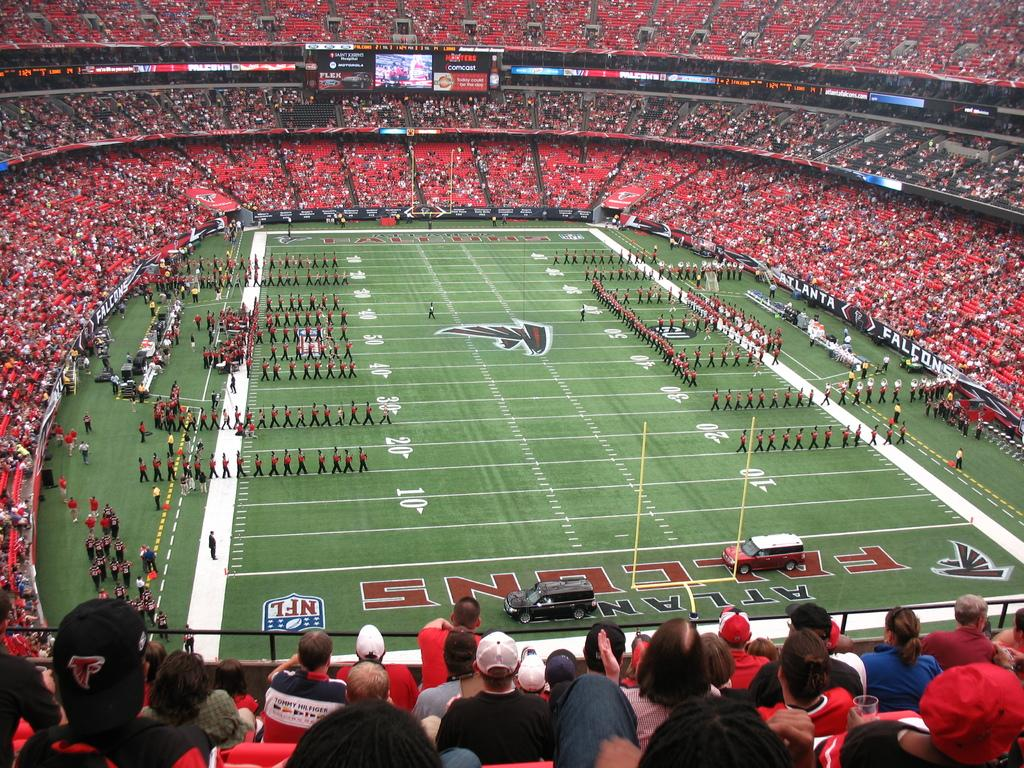What type of venue is depicted in the image? There is a stadium in the image. What is the color of the grass in the stadium? The grass in the stadium is green. What can be seen on the grass in the image? There are players on the grass. What color are the shirts worn by the audience in the image? The audience is wearing red shirts. What is located at the top of the image? There is a display at the top of the image. How can the score of the game be seen in the image? There is a scoreboard in the image. How many cherries are being held by the players in the image? There are no cherries present in the image; the players are playing a sport on the grass. What type of cherry-themed show is taking place in the image? There is no cherry-themed show present in the image; it is a sporting event at a stadium. 